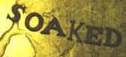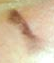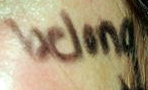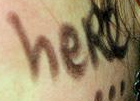What words are shown in these images in order, separated by a semicolon? SOAKED; I; belong; heRe 